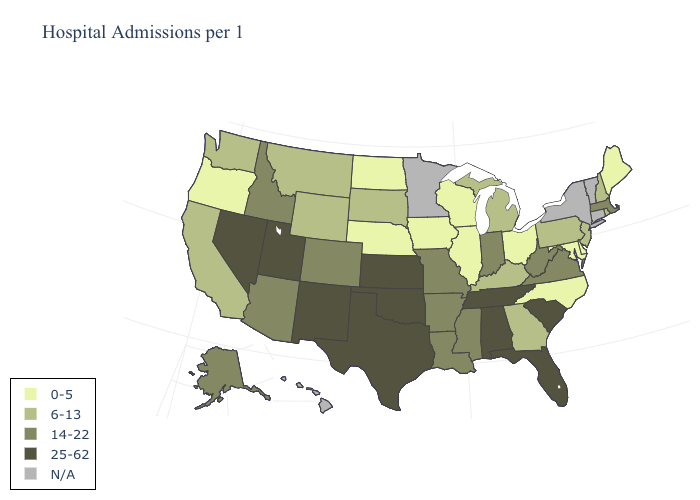What is the lowest value in states that border Pennsylvania?
Quick response, please. 0-5. What is the value of Illinois?
Short answer required. 0-5. What is the highest value in states that border Michigan?
Give a very brief answer. 14-22. Which states have the lowest value in the USA?
Be succinct. Delaware, Illinois, Iowa, Maine, Maryland, Nebraska, North Carolina, North Dakota, Ohio, Oregon, Wisconsin. Does Nebraska have the lowest value in the USA?
Give a very brief answer. Yes. Does Delaware have the lowest value in the South?
Be succinct. Yes. What is the highest value in states that border Vermont?
Quick response, please. 14-22. Among the states that border New Hampshire , which have the highest value?
Answer briefly. Massachusetts. What is the value of Connecticut?
Be succinct. N/A. Name the states that have a value in the range 0-5?
Keep it brief. Delaware, Illinois, Iowa, Maine, Maryland, Nebraska, North Carolina, North Dakota, Ohio, Oregon, Wisconsin. What is the value of California?
Quick response, please. 6-13. What is the highest value in the USA?
Write a very short answer. 25-62. Does California have the highest value in the West?
Short answer required. No. What is the highest value in states that border Alabama?
Concise answer only. 25-62. 